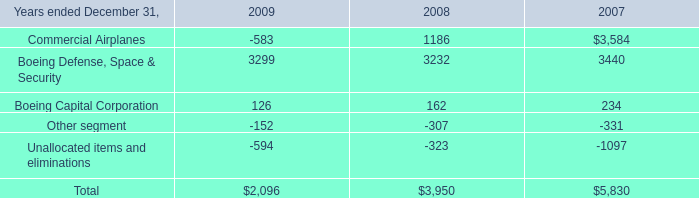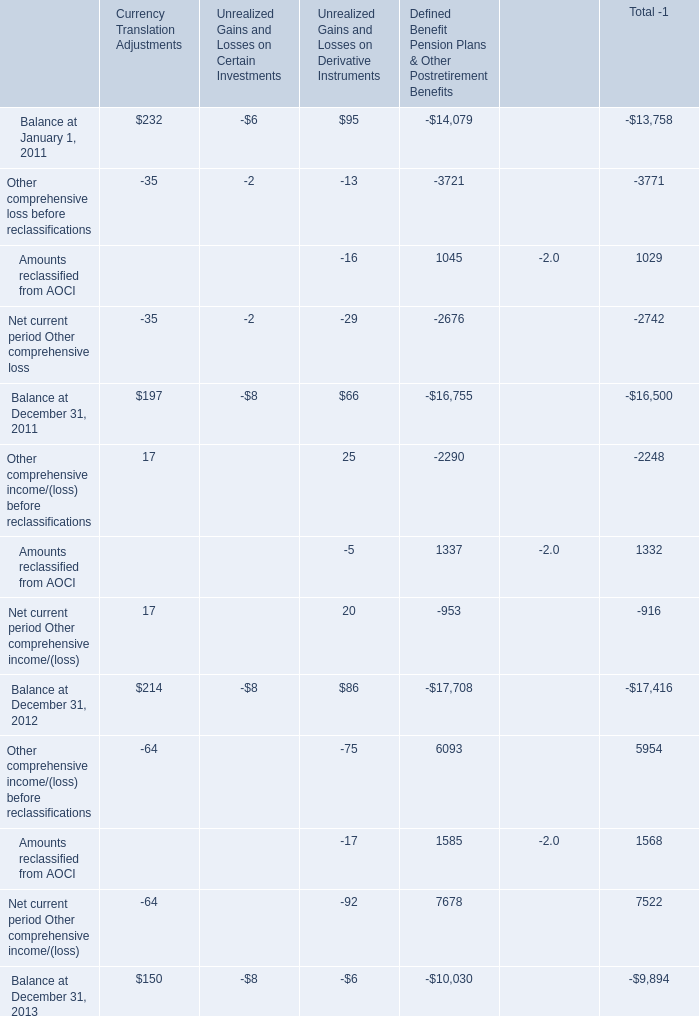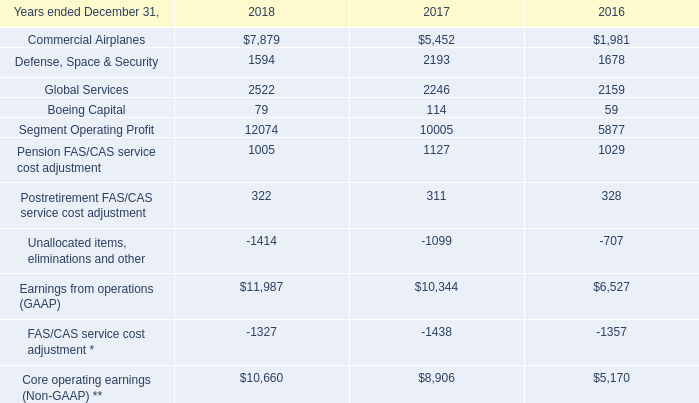What is the average amount of Pension FAS/CAS service cost adjustment of 2017, and Unallocated items and eliminations of 2007 ? 
Computations: ((1127.0 + 1097.0) / 2)
Answer: 1112.0. 